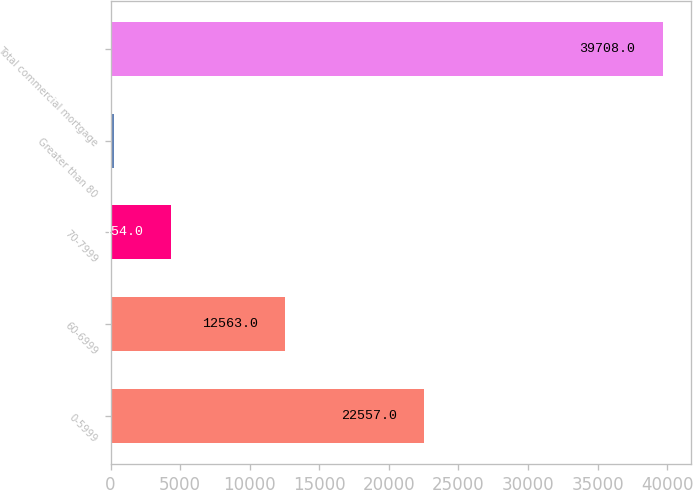Convert chart. <chart><loc_0><loc_0><loc_500><loc_500><bar_chart><fcel>0-5999<fcel>60-6999<fcel>70-7999<fcel>Greater than 80<fcel>Total commercial mortgage<nl><fcel>22557<fcel>12563<fcel>4354<fcel>234<fcel>39708<nl></chart> 